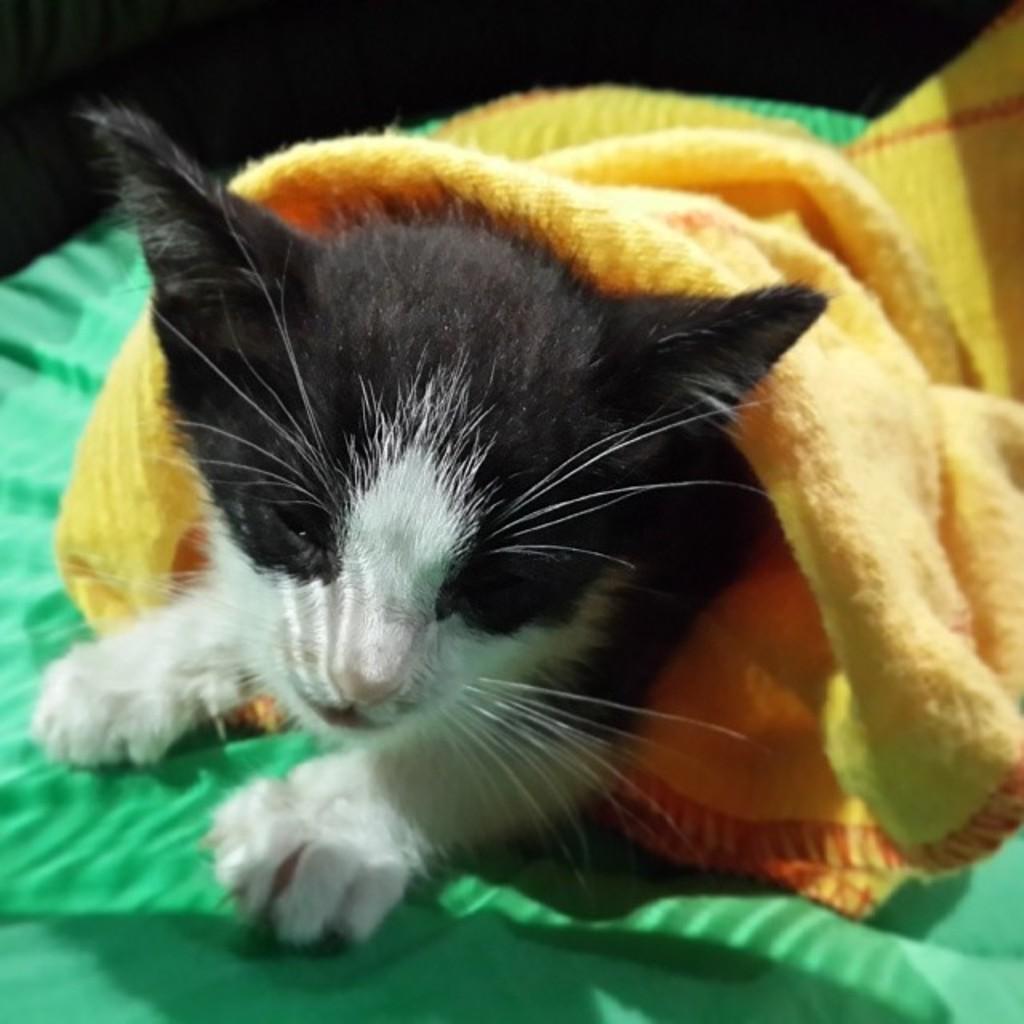Could you give a brief overview of what you see in this image? In the image I can see a cat on the green cloth and also I can see a yellow cloth on it. 